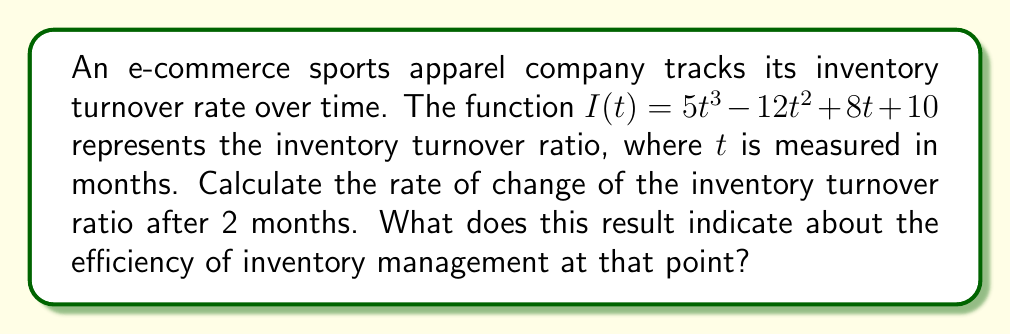Give your solution to this math problem. To solve this problem, we need to follow these steps:

1) The rate of change of the inventory turnover ratio is given by the derivative of $I(t)$ with respect to $t$.

2) Let's find the derivative $I'(t)$:
   $$I'(t) = \frac{d}{dt}(5t^3 - 12t^2 + 8t + 10)$$
   $$I'(t) = 15t^2 - 24t + 8$$

3) We need to evaluate this at $t = 2$ months:
   $$I'(2) = 15(2)^2 - 24(2) + 8$$
   $$I'(2) = 15(4) - 48 + 8$$
   $$I'(2) = 60 - 48 + 8 = 20$$

4) Interpretation: The rate of change of 20 indicates that after 2 months, the inventory turnover ratio is increasing at a rate of 20 units per month. This suggests that the efficiency of inventory management is improving rapidly at this point, as a higher inventory turnover ratio generally indicates more efficient inventory management.
Answer: 20 units per month, indicating rapidly improving inventory management efficiency. 